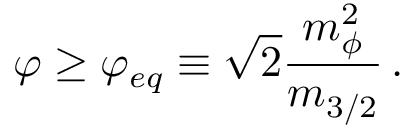<formula> <loc_0><loc_0><loc_500><loc_500>\varphi \geq \varphi _ { e q } \equiv \sqrt { 2 } \frac { m _ { \phi } ^ { 2 } } { m _ { 3 / 2 } } \, .</formula> 